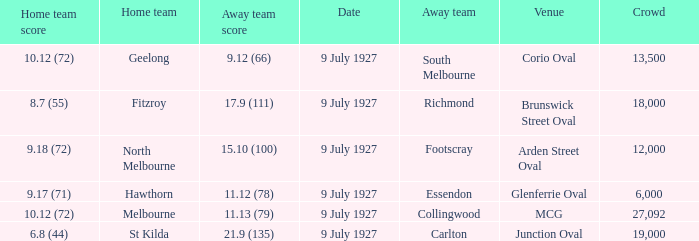How large was the crowd at Brunswick Street Oval? 18000.0. 